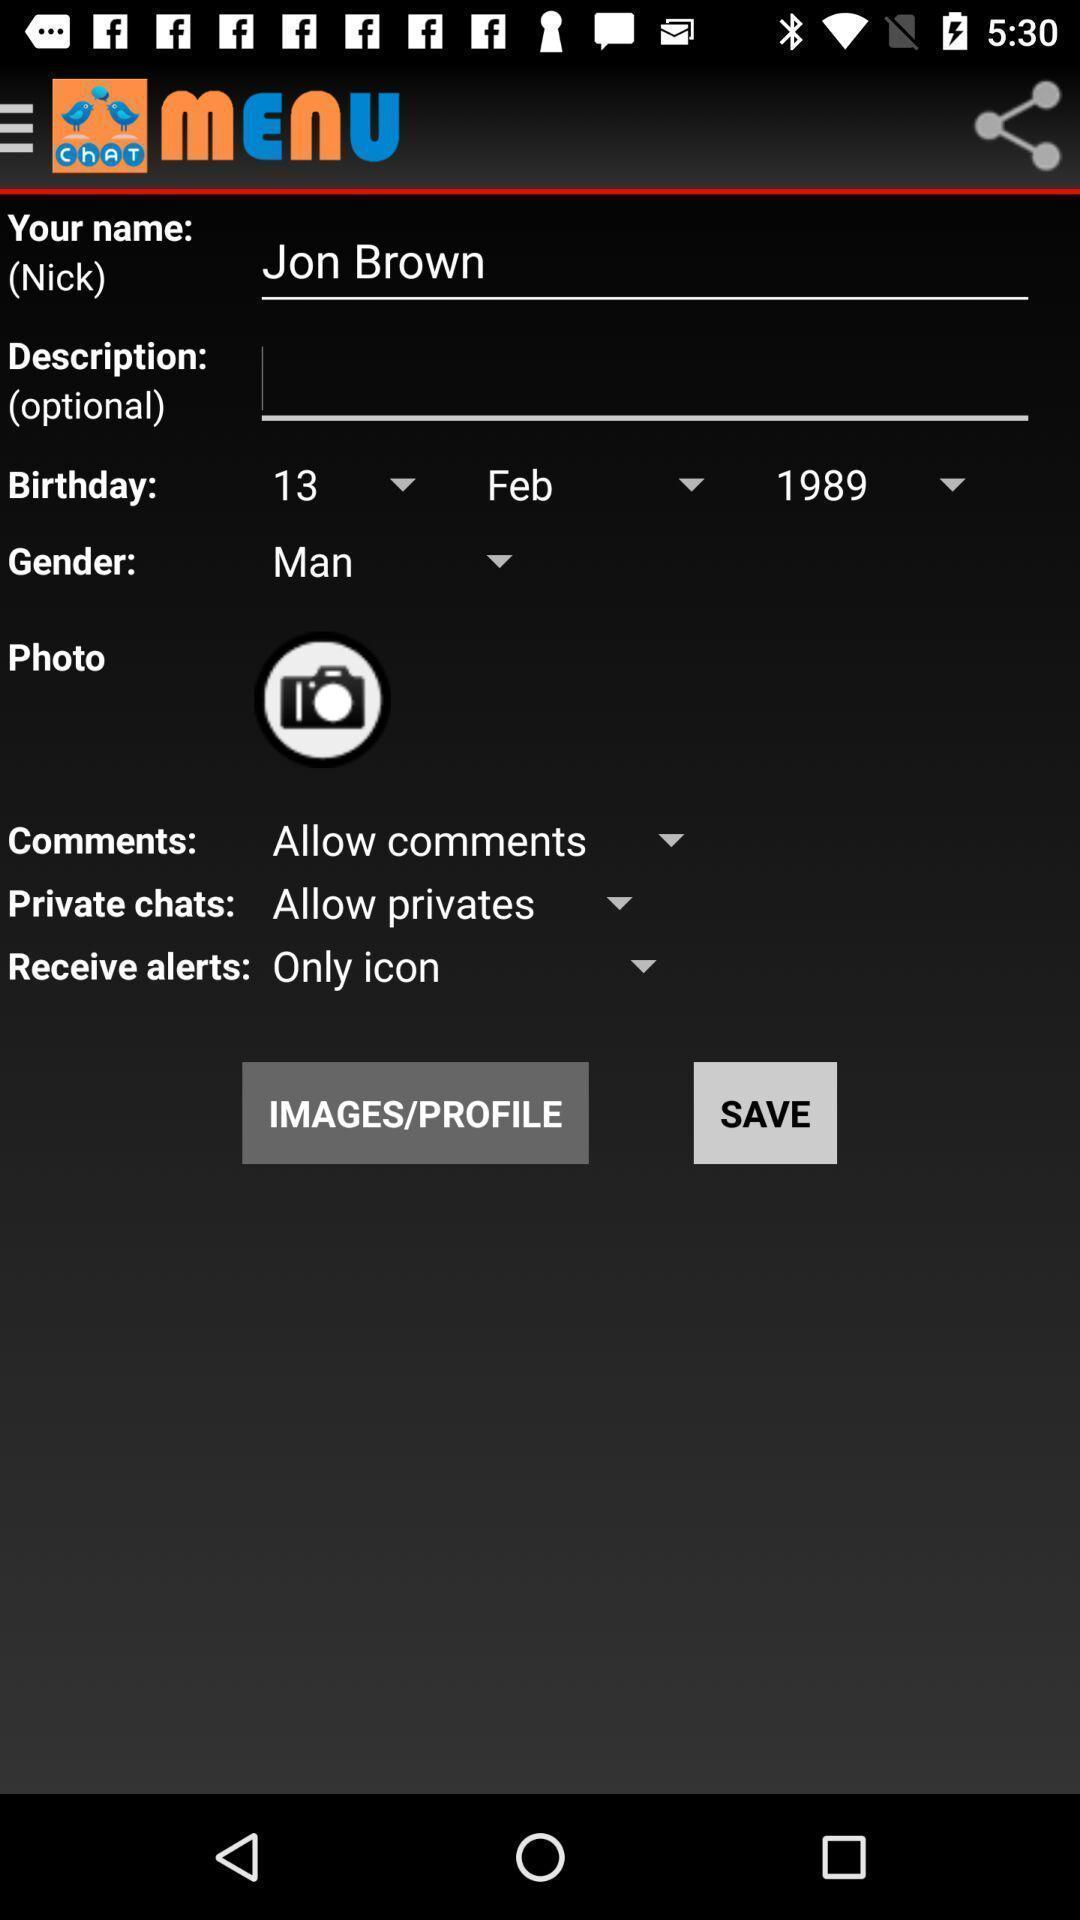Provide a detailed account of this screenshot. Profile page. 